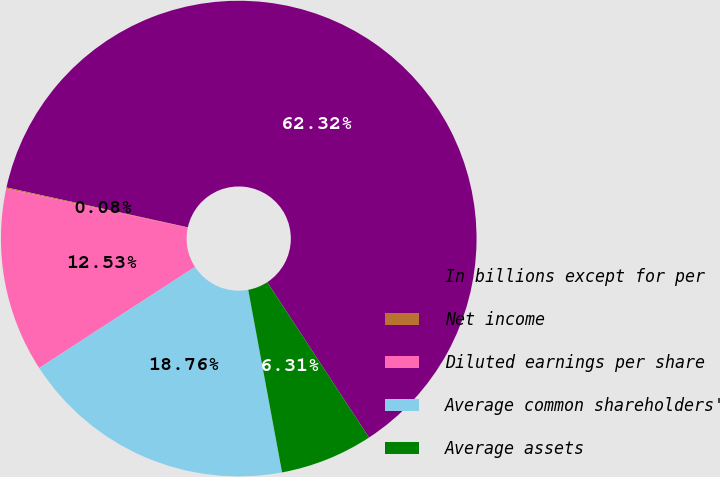Convert chart to OTSL. <chart><loc_0><loc_0><loc_500><loc_500><pie_chart><fcel>In billions except for per<fcel>Net income<fcel>Diluted earnings per share<fcel>Average common shareholders'<fcel>Average assets<nl><fcel>62.33%<fcel>0.08%<fcel>12.53%<fcel>18.76%<fcel>6.31%<nl></chart> 